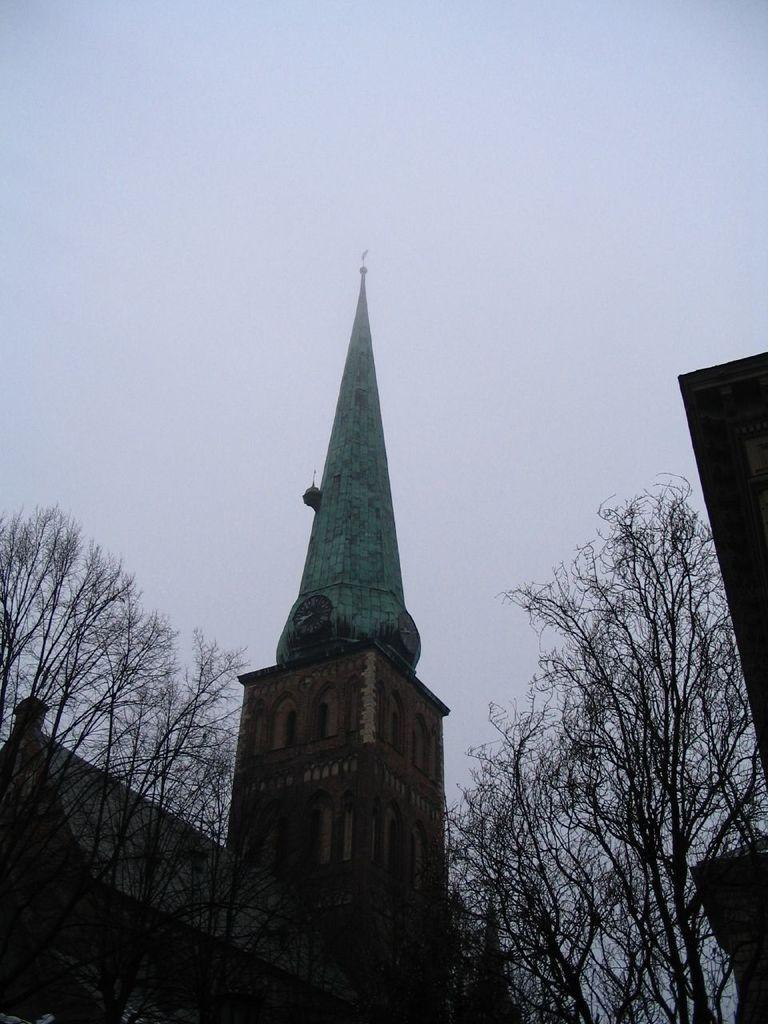What type of structure is present in the image? There is a building with windows in the image. What other natural elements can be seen in the image? There is a group of trees in the image. How would you describe the sky in the image? The sky is visible in the image and appears cloudy. Where is the fire located in the image? There is no fire present in the image. What type of fruit can be seen growing on the trees in the image? The image does not show any fruit growing on the trees; it only shows a group of trees. 